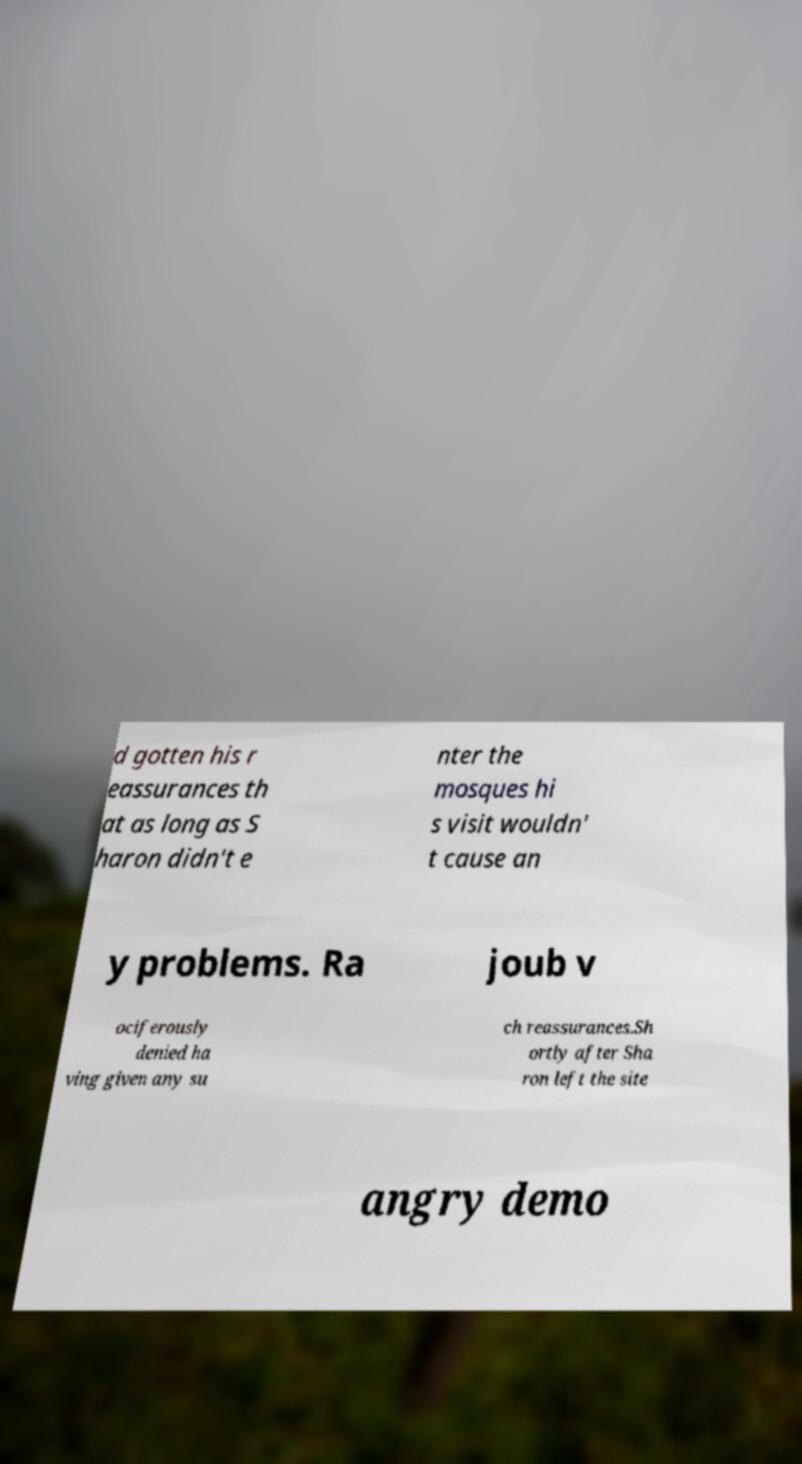Please identify and transcribe the text found in this image. d gotten his r eassurances th at as long as S haron didn't e nter the mosques hi s visit wouldn' t cause an y problems. Ra joub v ociferously denied ha ving given any su ch reassurances.Sh ortly after Sha ron left the site angry demo 